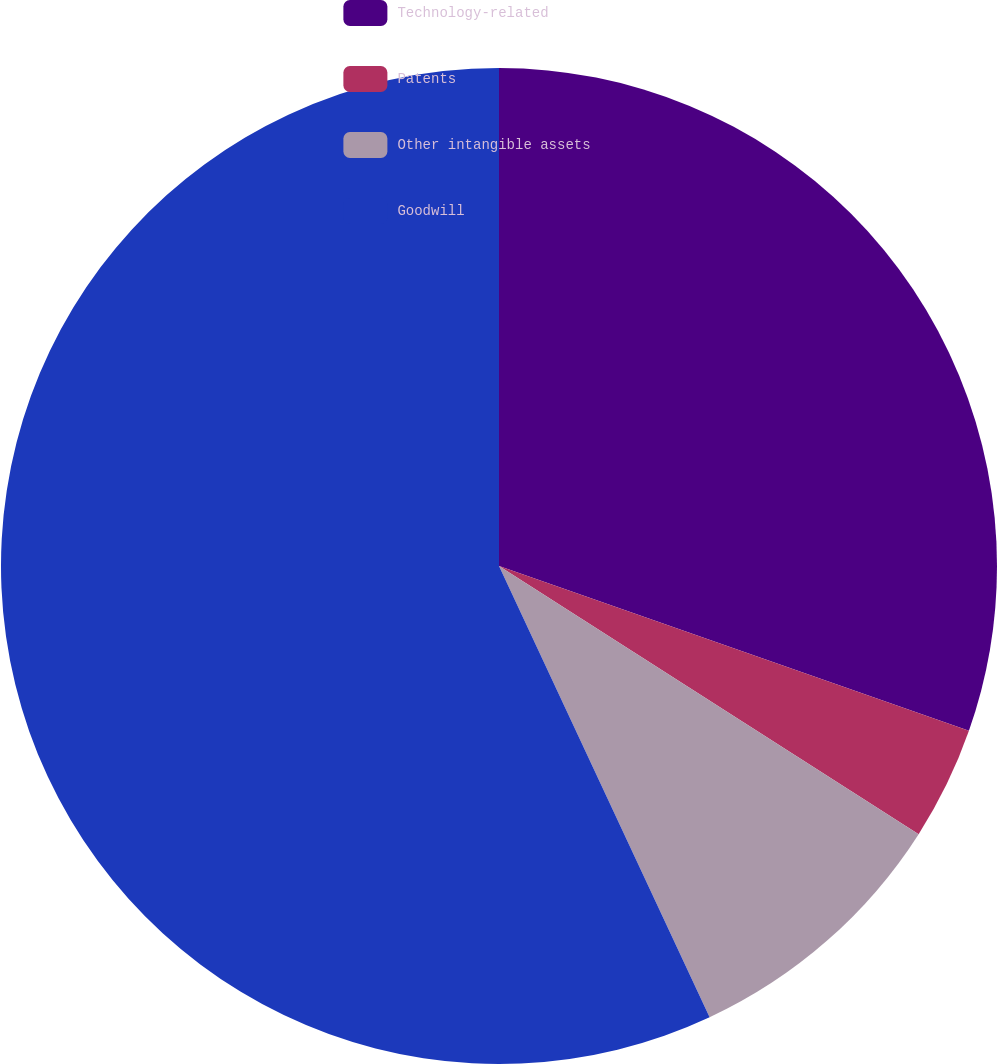Convert chart to OTSL. <chart><loc_0><loc_0><loc_500><loc_500><pie_chart><fcel>Technology-related<fcel>Patents<fcel>Other intangible assets<fcel>Goodwill<nl><fcel>30.37%<fcel>3.68%<fcel>9.0%<fcel>56.95%<nl></chart> 